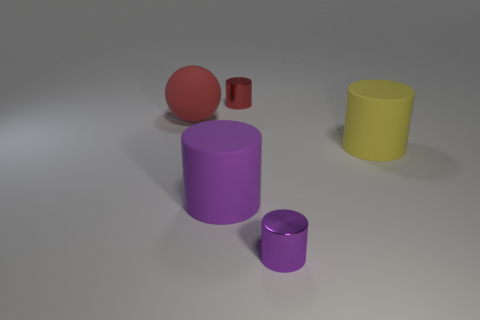How many large rubber cylinders are there?
Offer a very short reply. 2. The thing that is the same color as the large ball is what shape?
Provide a succinct answer. Cylinder. What size is the other metallic object that is the same shape as the tiny red metal object?
Keep it short and to the point. Small. There is a small shiny object in front of the big red object; is it the same shape as the red rubber thing?
Provide a short and direct response. No. What is the color of the rubber cylinder that is right of the red cylinder?
Provide a short and direct response. Yellow. How many other objects are there of the same size as the yellow object?
Make the answer very short. 2. Is there anything else that is the same shape as the big red matte thing?
Offer a terse response. No. Is the number of large objects behind the purple matte object the same as the number of big cylinders?
Provide a succinct answer. Yes. What number of large balls have the same material as the large purple cylinder?
Make the answer very short. 1. The other large cylinder that is the same material as the big yellow cylinder is what color?
Offer a very short reply. Purple. 